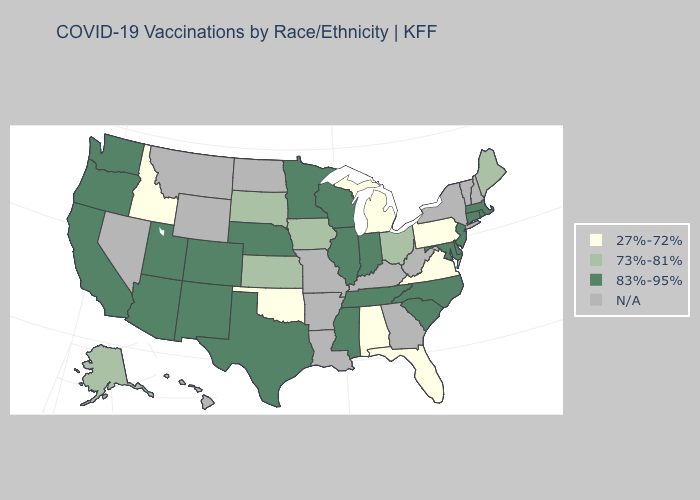What is the value of Pennsylvania?
Short answer required. 27%-72%. Which states have the highest value in the USA?
Give a very brief answer. Arizona, California, Colorado, Connecticut, Delaware, Illinois, Indiana, Maryland, Massachusetts, Minnesota, Mississippi, Nebraska, New Jersey, New Mexico, North Carolina, Oregon, Rhode Island, South Carolina, Tennessee, Texas, Utah, Washington, Wisconsin. Does the map have missing data?
Quick response, please. Yes. Name the states that have a value in the range 27%-72%?
Keep it brief. Alabama, Florida, Idaho, Michigan, Oklahoma, Pennsylvania, Virginia. Does the first symbol in the legend represent the smallest category?
Answer briefly. Yes. What is the value of Tennessee?
Answer briefly. 83%-95%. Name the states that have a value in the range 83%-95%?
Keep it brief. Arizona, California, Colorado, Connecticut, Delaware, Illinois, Indiana, Maryland, Massachusetts, Minnesota, Mississippi, Nebraska, New Jersey, New Mexico, North Carolina, Oregon, Rhode Island, South Carolina, Tennessee, Texas, Utah, Washington, Wisconsin. Name the states that have a value in the range 27%-72%?
Be succinct. Alabama, Florida, Idaho, Michigan, Oklahoma, Pennsylvania, Virginia. Does Washington have the highest value in the USA?
Write a very short answer. Yes. Which states have the highest value in the USA?
Short answer required. Arizona, California, Colorado, Connecticut, Delaware, Illinois, Indiana, Maryland, Massachusetts, Minnesota, Mississippi, Nebraska, New Jersey, New Mexico, North Carolina, Oregon, Rhode Island, South Carolina, Tennessee, Texas, Utah, Washington, Wisconsin. What is the lowest value in the Northeast?
Be succinct. 27%-72%. Does South Dakota have the highest value in the MidWest?
Keep it brief. No. 